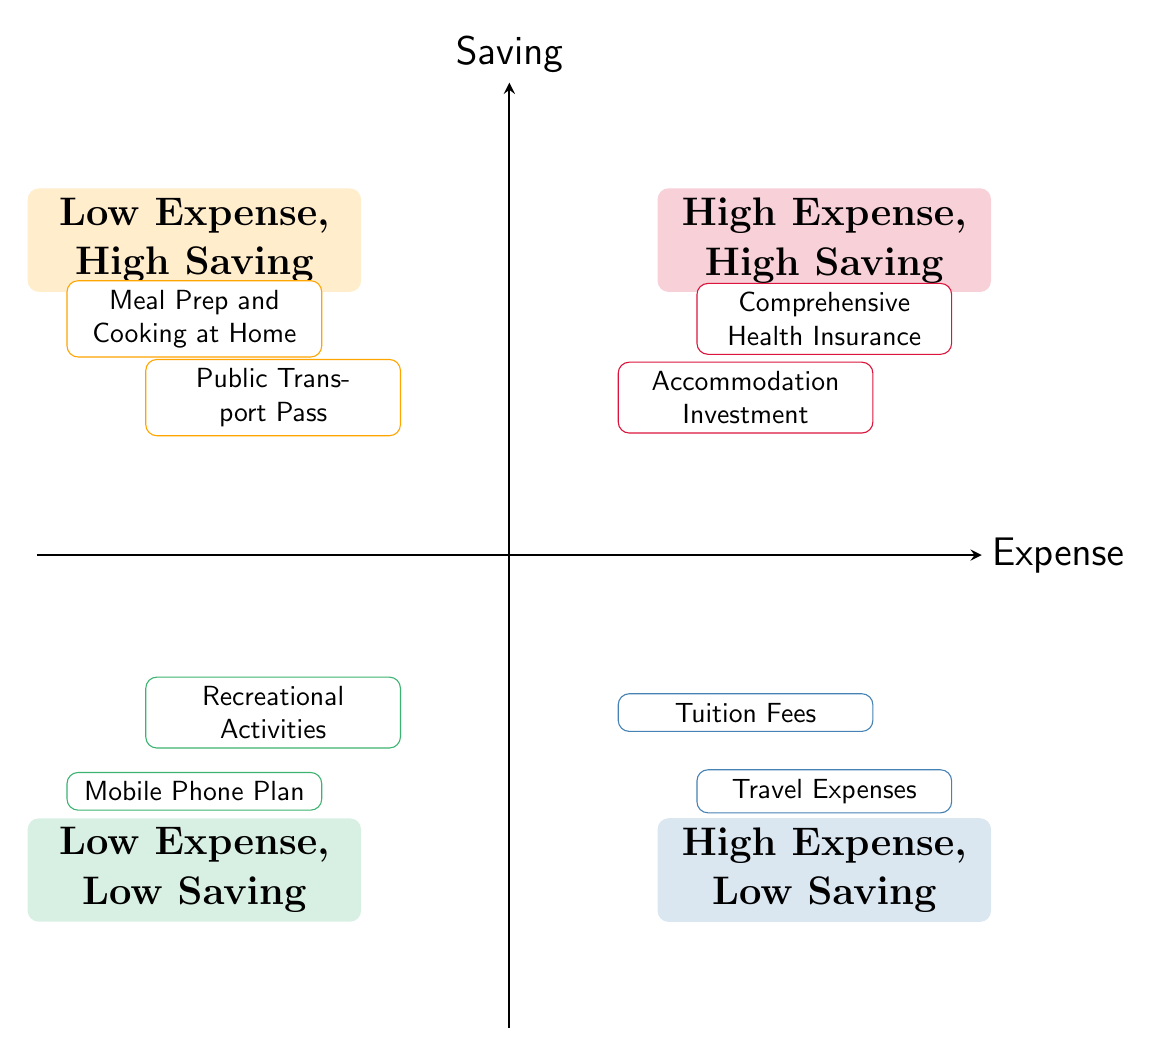What are the two elements in the "High Expense, Low Saving" quadrant? In the "High Expense, Low Saving" quadrant, there are two elements named "Tuition Fees" and "Travel Expenses." These elements are listed in that specific quadrant in the diagram, indicating they fall under high expenses with low savings potential.
Answer: Tuition Fees, Travel Expenses Which quadrant contains "Public Transport Pass"? The "Public Transport Pass" is located in the "Low Expense, High Saving" quadrant. This is determined by finding the specific element within the diagram and identifying its quadrant placement.
Answer: Low Expense, High Saving How many elements are categorized as "High Expense, High Saving"? The "High Expense, High Saving" quadrant contains two elements: "Accommodation Investment" and "Comprehensive Health Insurance." Counting these gives the total number of elements in that category.
Answer: 2 Which expense has a description focusing on health coverage? The element "Comprehensive Health Insurance" has a description concerning health coverage, specifically mentioned as paying a higher premium for extensive health coverage to avoid unexpected medical expenses.
Answer: Comprehensive Health Insurance What can be inferred about the relationship between "Meal Prep and Cooking at Home" and "Recreational Activities"? "Meal Prep and Cooking at Home" is in the "Low Expense, High Saving" quadrant, while "Recreational Activities" is in the "Low Expense, Low Saving" quadrant. This indicates that while both involve low expenses, "Meal Prep" promotes saving more effectively than "Recreational Activities."
Answer: Different savings potential What is the main focus of the "High Expense, High Saving" quadrant? The main focus of the "High Expense, High Saving" quadrant is investing more upfront (higher expense) for long-term benefits (high saving potential). This is illustrated by elements like "Accommodation Investment" and "Comprehensive Health Insurance," which emphasize strategic spending.
Answer: Investing for long-term benefits 